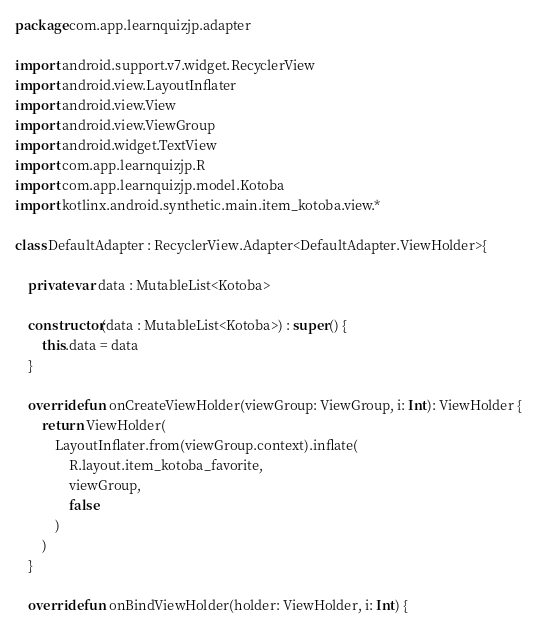<code> <loc_0><loc_0><loc_500><loc_500><_Kotlin_>package com.app.learnquizjp.adapter

import android.support.v7.widget.RecyclerView
import android.view.LayoutInflater
import android.view.View
import android.view.ViewGroup
import android.widget.TextView
import com.app.learnquizjp.R
import com.app.learnquizjp.model.Kotoba
import kotlinx.android.synthetic.main.item_kotoba.view.*

class DefaultAdapter : RecyclerView.Adapter<DefaultAdapter.ViewHolder>{

    private var data : MutableList<Kotoba>

    constructor(data : MutableList<Kotoba>) : super() {
        this.data = data
    }

    override fun onCreateViewHolder(viewGroup: ViewGroup, i: Int): ViewHolder {
        return ViewHolder(
            LayoutInflater.from(viewGroup.context).inflate(
                R.layout.item_kotoba_favorite,
                viewGroup,
                false
            )
        )
    }

    override fun onBindViewHolder(holder: ViewHolder, i: Int) {</code> 